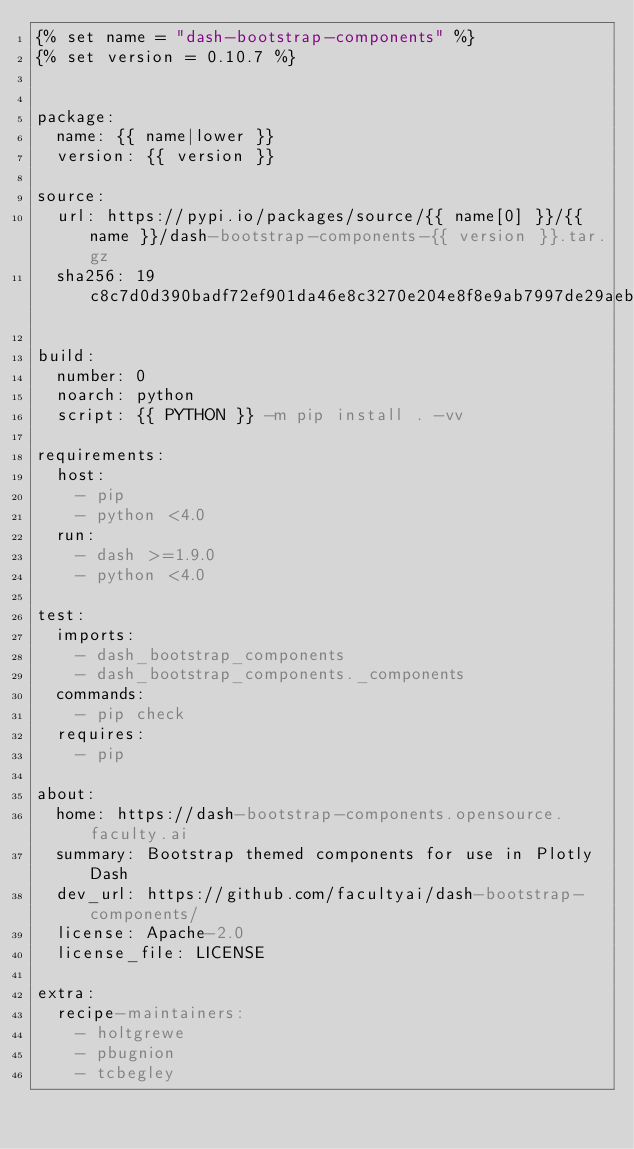Convert code to text. <code><loc_0><loc_0><loc_500><loc_500><_YAML_>{% set name = "dash-bootstrap-components" %}
{% set version = 0.10.7 %}


package:
  name: {{ name|lower }}
  version: {{ version }}

source:
  url: https://pypi.io/packages/source/{{ name[0] }}/{{ name }}/dash-bootstrap-components-{{ version }}.tar.gz
  sha256: 19c8c7d0d390badf72ef901da46e8c3270e204e8f8e9ab7997de29aeb39ad7b9

build:
  number: 0
  noarch: python
  script: {{ PYTHON }} -m pip install . -vv

requirements:
  host:
    - pip
    - python <4.0
  run:
    - dash >=1.9.0
    - python <4.0

test:
  imports:
    - dash_bootstrap_components
    - dash_bootstrap_components._components
  commands:
    - pip check
  requires:
    - pip

about:
  home: https://dash-bootstrap-components.opensource.faculty.ai
  summary: Bootstrap themed components for use in Plotly Dash
  dev_url: https://github.com/facultyai/dash-bootstrap-components/
  license: Apache-2.0
  license_file: LICENSE

extra:
  recipe-maintainers:
    - holtgrewe
    - pbugnion
    - tcbegley
</code> 